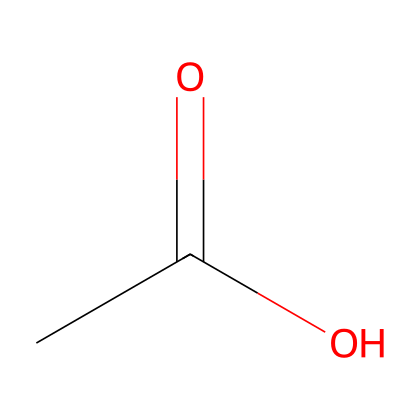What is the chemical name of the compound represented by this SMILES? The SMILES representation CC(=O)O corresponds to acetic acid, which is a common carboxylic acid. The structure contains a carbonyl group (C=O) and a hydroxyl group (–OH) attached to a carbon atom.
Answer: acetic acid How many carbon atoms are in acetic acid? In the SMILES CC(=O)O, the 'CC' part indicates that there are two carbon atoms; one is part of the carbonyl group and the other is connected to the carboxyl group.
Answer: two What type of functional group is present in acetic acid? The structure CC(=O)O identifies a carboxyl functional group (–COOH), characteristic of carboxylic acids, with a carbonyl and a hydroxyl group bonded to the carbon atom.
Answer: carboxyl What is the oxidation state of the carbon in the carboxylic acid group of acetic acid? The carbon in the carboxylic acid group has a oxidation state of +3. In terms of bonding, the carbon bonded to two oxygen atoms (one double bond and one single bond) and one hydrogen atom leads to an oxidation state calculated from the number of bonds to more electronegative atoms minus the number of hydrogens.
Answer: +3 How many hydrogen atoms are in acetic acid? The structure CC(=O)O indicates there are four hydrogen atoms in total: three bonded to one carbon atom and one in the hydroxyl (-OH) part of the carboxyl group.
Answer: four Is acetic acid considered a strong or weak acid? Acetic acid is characterized as a weak acid because it does not completely dissociate in water, only partially ionizing to form acetate ions and hydrogen ions.
Answer: weak What effect does the presence of the carboxyl group have on acetic acid's acidity? The carboxyl group makes acetic acid a weak acid by facilitating the release of protons (H+) in solution. The stability of the acetate ion formed after dissociation contributes to its ability to lose hydrogen ions.
Answer: increases acidity 